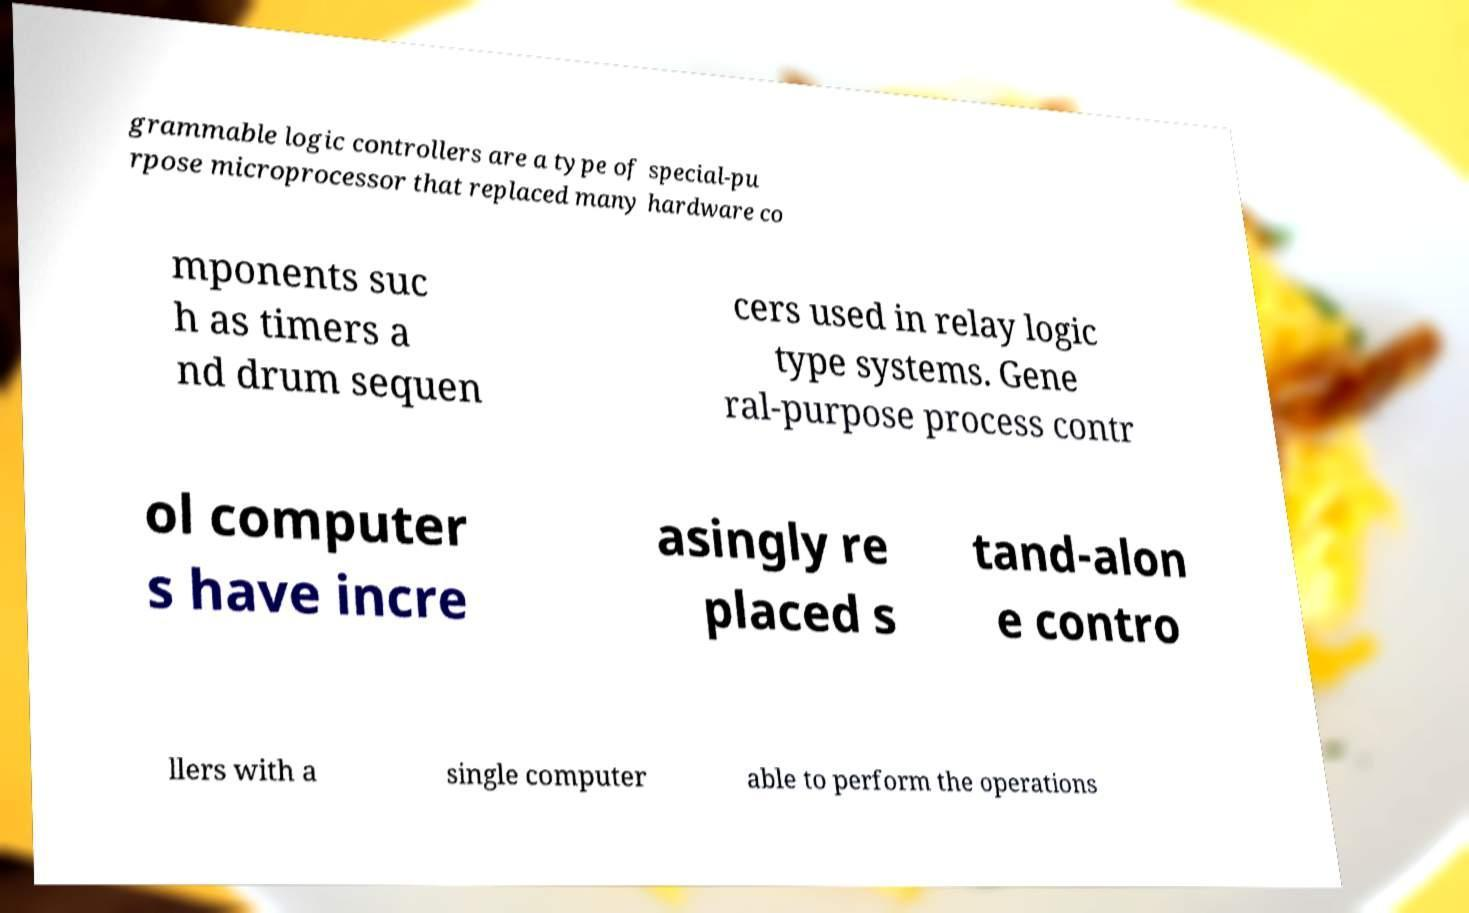Please identify and transcribe the text found in this image. grammable logic controllers are a type of special-pu rpose microprocessor that replaced many hardware co mponents suc h as timers a nd drum sequen cers used in relay logic type systems. Gene ral-purpose process contr ol computer s have incre asingly re placed s tand-alon e contro llers with a single computer able to perform the operations 